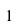Convert formula to latex. <formula><loc_0><loc_0><loc_500><loc_500>\null { 1 } \null</formula> 